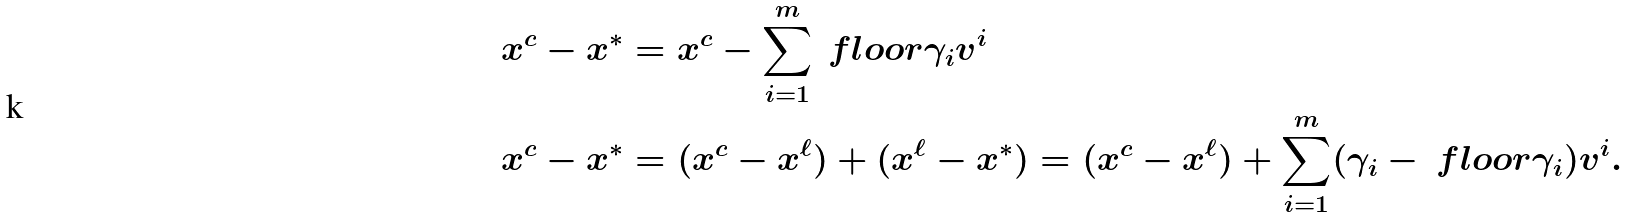<formula> <loc_0><loc_0><loc_500><loc_500>& x ^ { c } - x ^ { * } = x ^ { c } - \sum _ { i = 1 } ^ { m } \ f l o o r { \gamma _ { i } } v ^ { i } \\ & x ^ { c } - x ^ { * } = ( x ^ { c } - x ^ { \ell } ) + ( x ^ { \ell } - x ^ { * } ) = ( x ^ { c } - x ^ { \ell } ) + \sum _ { i = 1 } ^ { m } ( \gamma _ { i } - \ f l o o r { \gamma _ { i } } ) v ^ { i } .</formula> 